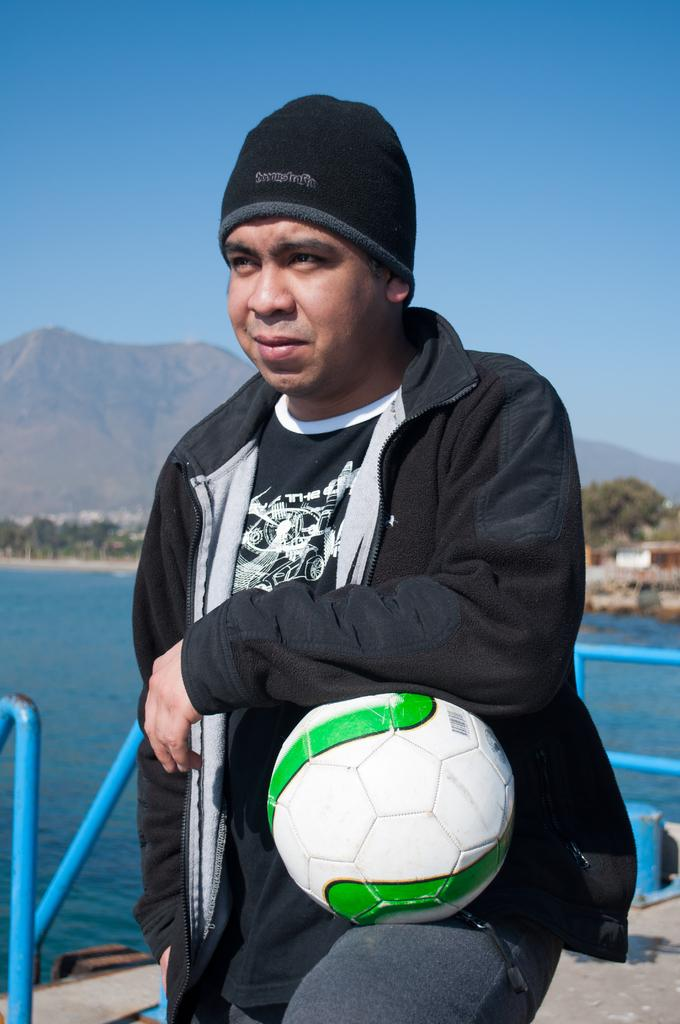What is the main subject of the image? There is a person in the image. What is the person holding in the image? The person is holding a ball. What can be seen in the background of the image? There is water, mountains, and the sky visible in the background of the image. What type of camera is the person using to take a picture of the duck in the image? There is no camera or duck present in the image. 